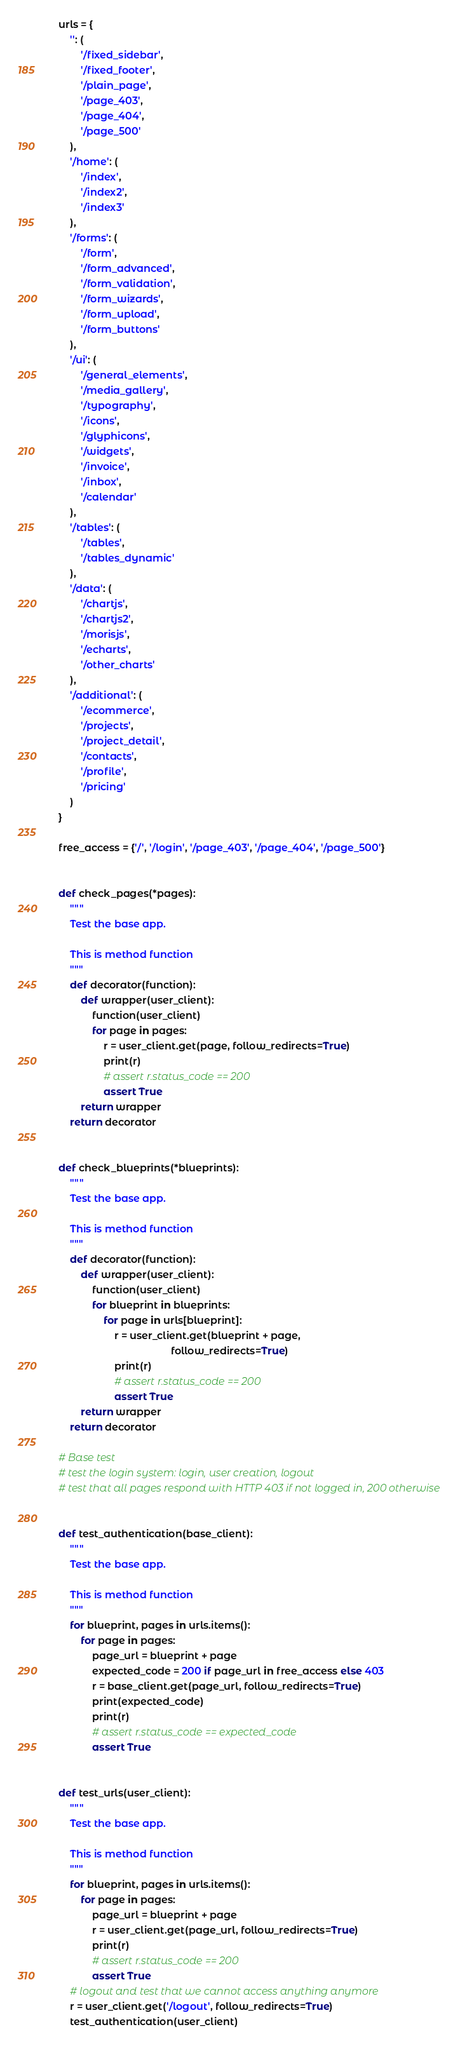Convert code to text. <code><loc_0><loc_0><loc_500><loc_500><_Python_>
urls = {
    '': (
        '/fixed_sidebar',
        '/fixed_footer',
        '/plain_page',
        '/page_403',
        '/page_404',
        '/page_500'
    ),
    '/home': (
        '/index',
        '/index2',
        '/index3'
    ),
    '/forms': (
        '/form',
        '/form_advanced',
        '/form_validation',
        '/form_wizards',
        '/form_upload',
        '/form_buttons'
    ),
    '/ui': (
        '/general_elements',
        '/media_gallery',
        '/typography',
        '/icons',
        '/glyphicons',
        '/widgets',
        '/invoice',
        '/inbox',
        '/calendar'
    ),
    '/tables': (
        '/tables',
        '/tables_dynamic'
    ),
    '/data': (
        '/chartjs',
        '/chartjs2',
        '/morisjs',
        '/echarts',
        '/other_charts'
    ),
    '/additional': (
        '/ecommerce',
        '/projects',
        '/project_detail',
        '/contacts',
        '/profile',
        '/pricing'
    )
}

free_access = {'/', '/login', '/page_403', '/page_404', '/page_500'}


def check_pages(*pages):
    """
    Test the base app.

    This is method function
    """
    def decorator(function):
        def wrapper(user_client):
            function(user_client)
            for page in pages:
                r = user_client.get(page, follow_redirects=True)
                print(r)
                # assert r.status_code == 200
                assert True
        return wrapper
    return decorator


def check_blueprints(*blueprints):
    """
    Test the base app.

    This is method function
    """
    def decorator(function):
        def wrapper(user_client):
            function(user_client)
            for blueprint in blueprints:
                for page in urls[blueprint]:
                    r = user_client.get(blueprint + page,
                                        follow_redirects=True)
                    print(r)
                    # assert r.status_code == 200
                    assert True
        return wrapper
    return decorator

# Base test
# test the login system: login, user creation, logout
# test that all pages respond with HTTP 403 if not logged in, 200 otherwise


def test_authentication(base_client):
    """
    Test the base app.

    This is method function
    """
    for blueprint, pages in urls.items():
        for page in pages:
            page_url = blueprint + page
            expected_code = 200 if page_url in free_access else 403
            r = base_client.get(page_url, follow_redirects=True)
            print(expected_code)
            print(r)
            # assert r.status_code == expected_code
            assert True


def test_urls(user_client):
    """
    Test the base app.

    This is method function
    """
    for blueprint, pages in urls.items():
        for page in pages:
            page_url = blueprint + page
            r = user_client.get(page_url, follow_redirects=True)
            print(r)
            # assert r.status_code == 200
            assert True
    # logout and test that we cannot access anything anymore
    r = user_client.get('/logout', follow_redirects=True)
    test_authentication(user_client)
</code> 